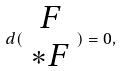<formula> <loc_0><loc_0><loc_500><loc_500>d ( \begin{array} { c } F \\ * F \end{array} ) = 0 ,</formula> 